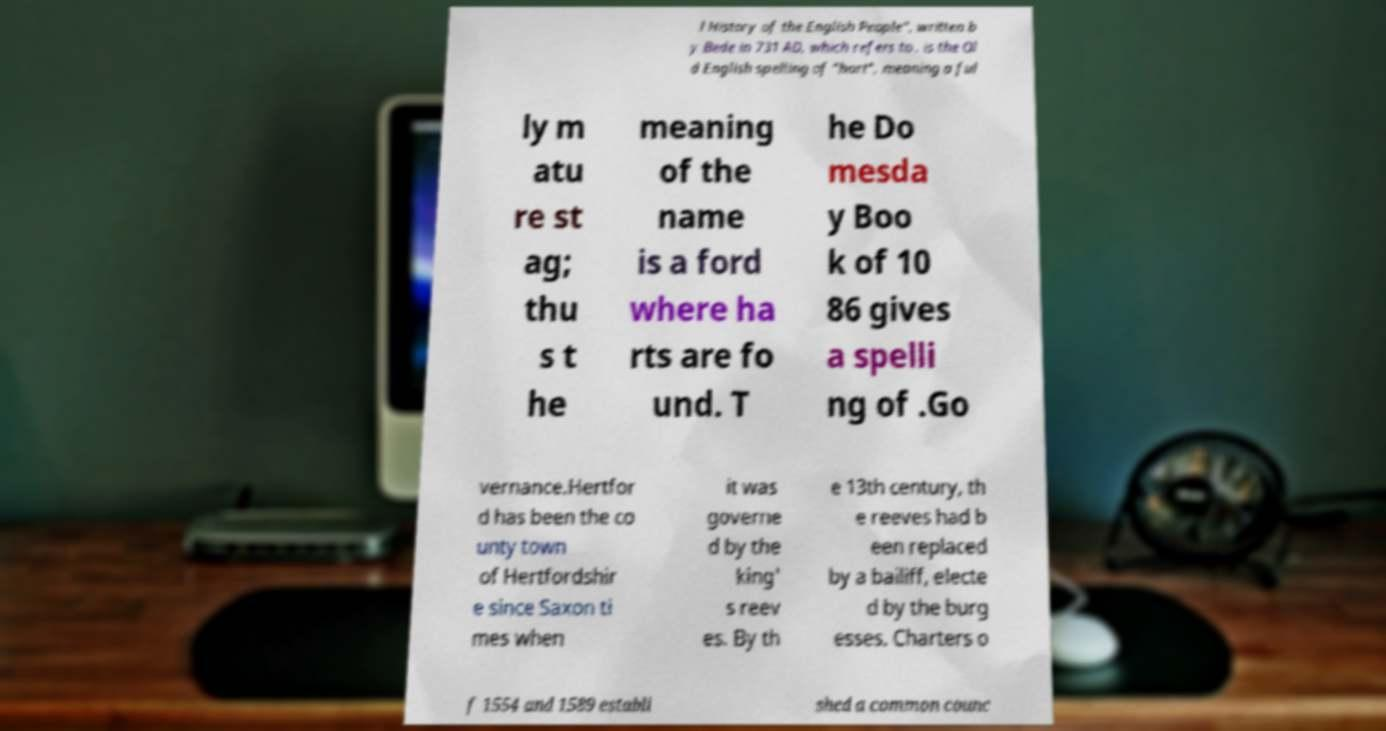Can you accurately transcribe the text from the provided image for me? l History of the English People", written b y Bede in 731 AD, which refers to . is the Ol d English spelling of "hart", meaning a ful ly m atu re st ag; thu s t he meaning of the name is a ford where ha rts are fo und. T he Do mesda y Boo k of 10 86 gives a spelli ng of .Go vernance.Hertfor d has been the co unty town of Hertfordshir e since Saxon ti mes when it was governe d by the king' s reev es. By th e 13th century, th e reeves had b een replaced by a bailiff, electe d by the burg esses. Charters o f 1554 and 1589 establi shed a common counc 